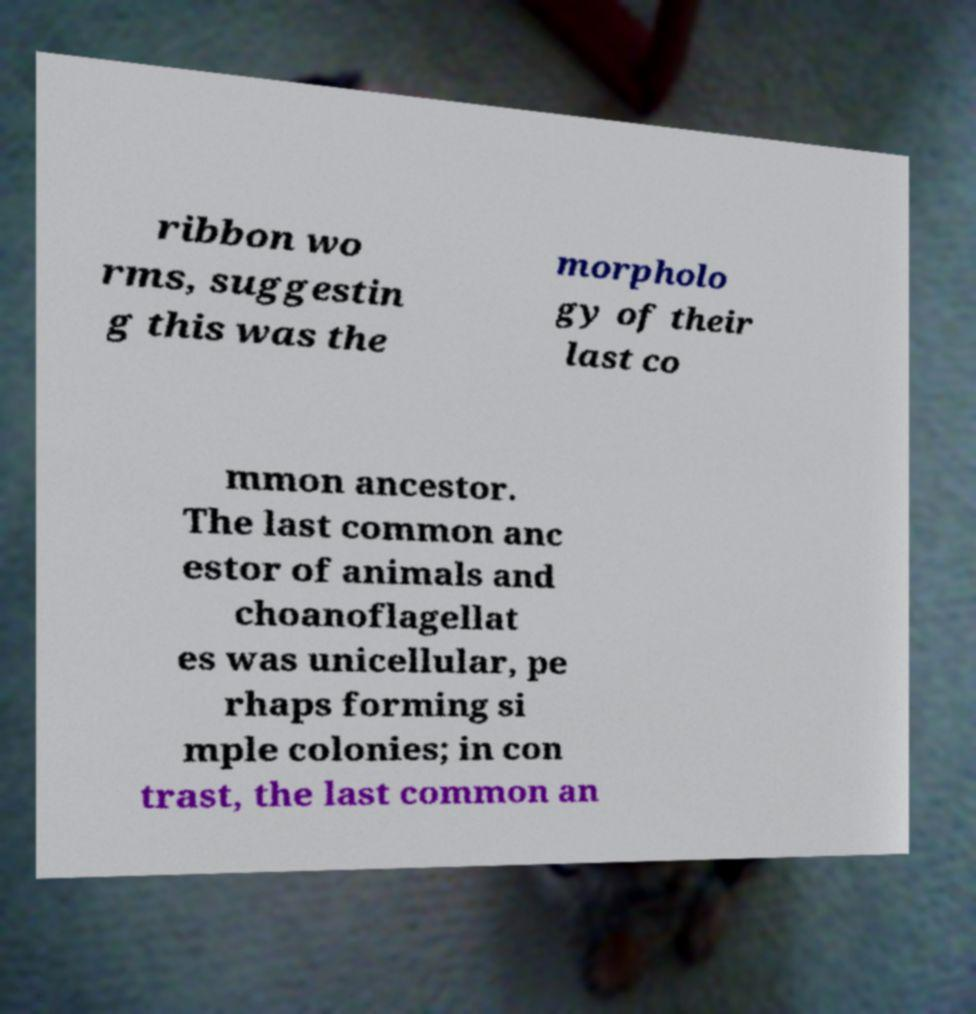What messages or text are displayed in this image? I need them in a readable, typed format. ribbon wo rms, suggestin g this was the morpholo gy of their last co mmon ancestor. The last common anc estor of animals and choanoflagellat es was unicellular, pe rhaps forming si mple colonies; in con trast, the last common an 